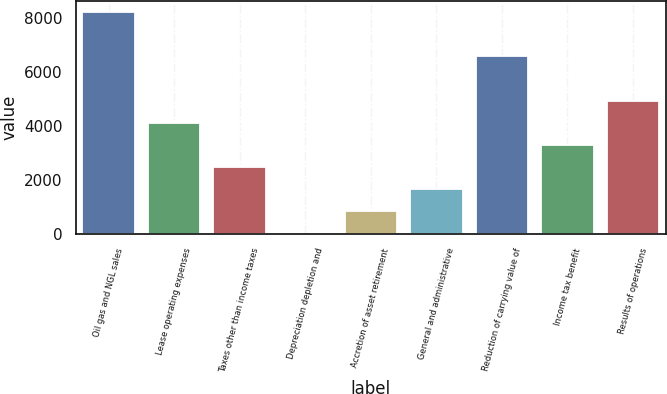<chart> <loc_0><loc_0><loc_500><loc_500><bar_chart><fcel>Oil gas and NGL sales<fcel>Lease operating expenses<fcel>Taxes other than income taxes<fcel>Depreciation depletion and<fcel>Accretion of asset retirement<fcel>General and administrative<fcel>Reduction of carrying value of<fcel>Income tax benefit<fcel>Results of operations<nl><fcel>8206<fcel>4109.16<fcel>2470.42<fcel>12.31<fcel>831.68<fcel>1651.05<fcel>6567.27<fcel>3289.79<fcel>4928.53<nl></chart> 